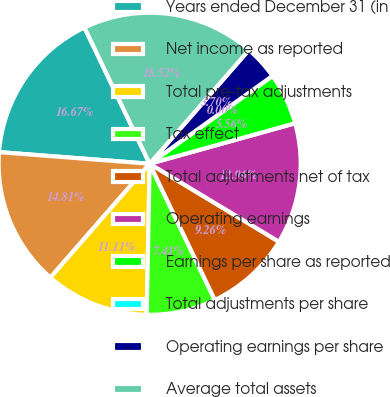<chart> <loc_0><loc_0><loc_500><loc_500><pie_chart><fcel>Years ended December 31 (in<fcel>Net income as reported<fcel>Total pre-tax adjustments<fcel>Tax effect<fcel>Total adjustments net of tax<fcel>Operating earnings<fcel>Earnings per share as reported<fcel>Total adjustments per share<fcel>Operating earnings per share<fcel>Average total assets<nl><fcel>16.67%<fcel>14.81%<fcel>11.11%<fcel>7.41%<fcel>9.26%<fcel>12.96%<fcel>5.56%<fcel>0.0%<fcel>3.7%<fcel>18.52%<nl></chart> 